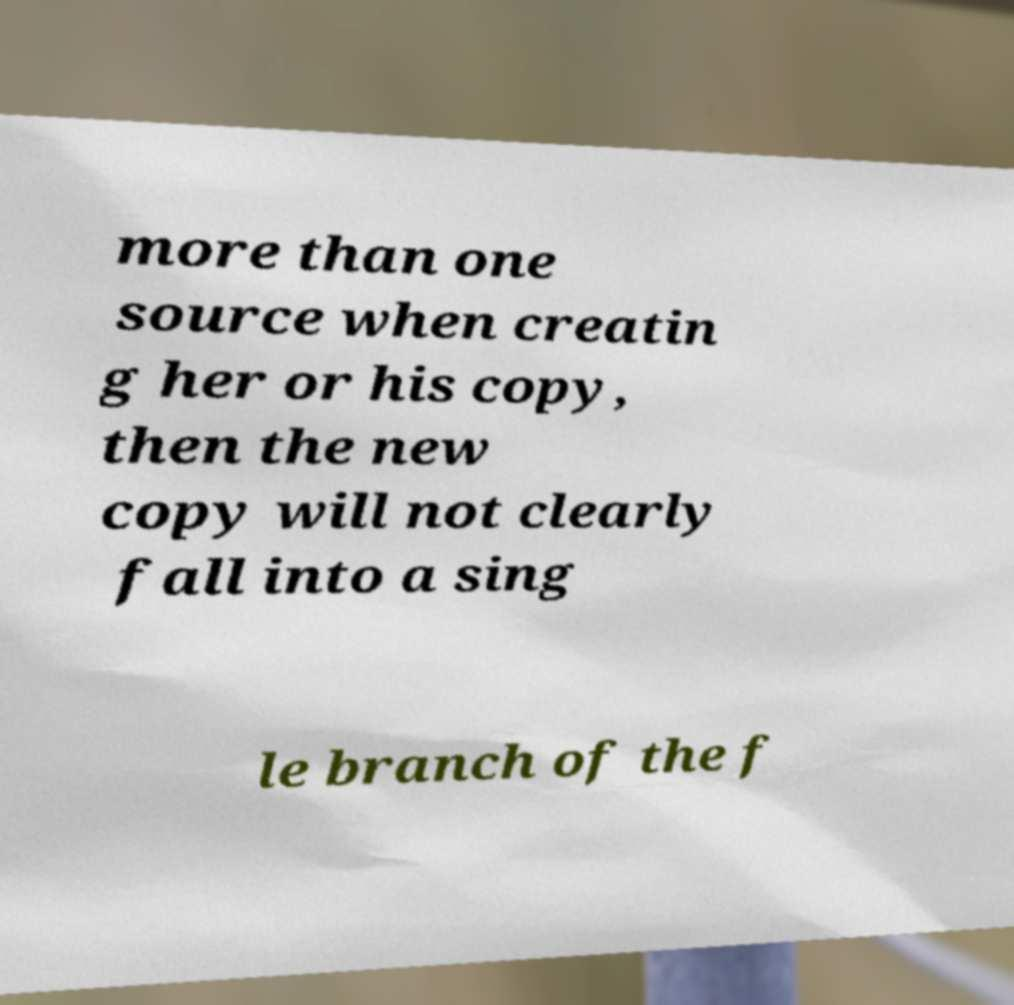Please identify and transcribe the text found in this image. more than one source when creatin g her or his copy, then the new copy will not clearly fall into a sing le branch of the f 